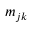<formula> <loc_0><loc_0><loc_500><loc_500>m _ { j k }</formula> 